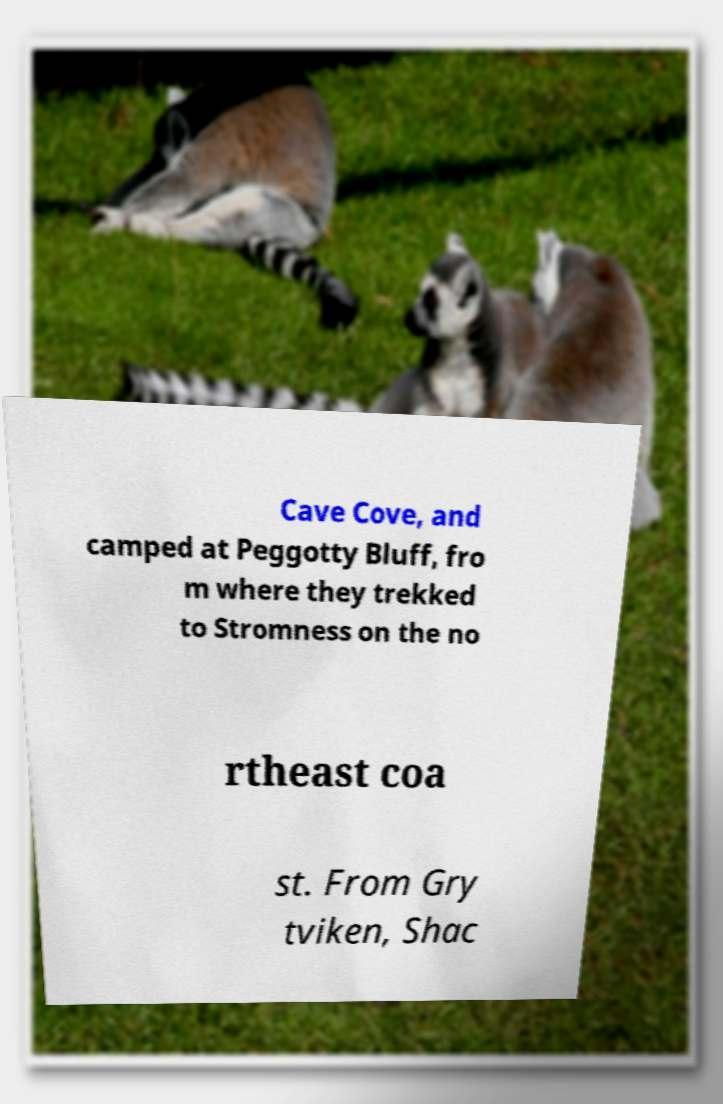Could you assist in decoding the text presented in this image and type it out clearly? Cave Cove, and camped at Peggotty Bluff, fro m where they trekked to Stromness on the no rtheast coa st. From Gry tviken, Shac 